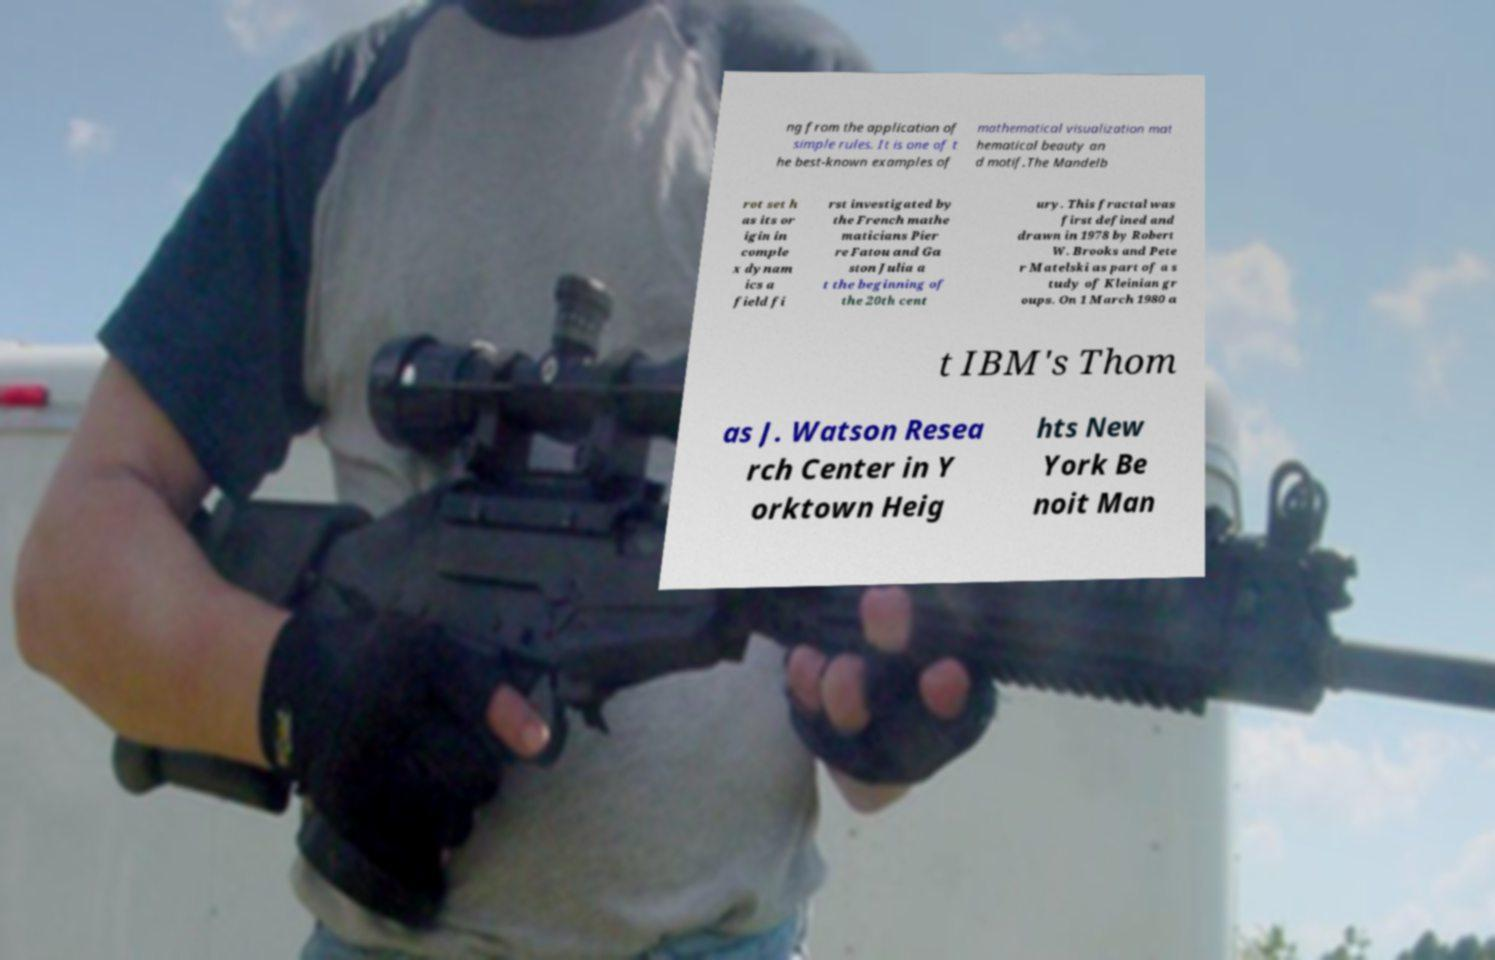Please read and relay the text visible in this image. What does it say? ng from the application of simple rules. It is one of t he best-known examples of mathematical visualization mat hematical beauty an d motif.The Mandelb rot set h as its or igin in comple x dynam ics a field fi rst investigated by the French mathe maticians Pier re Fatou and Ga ston Julia a t the beginning of the 20th cent ury. This fractal was first defined and drawn in 1978 by Robert W. Brooks and Pete r Matelski as part of a s tudy of Kleinian gr oups. On 1 March 1980 a t IBM's Thom as J. Watson Resea rch Center in Y orktown Heig hts New York Be noit Man 